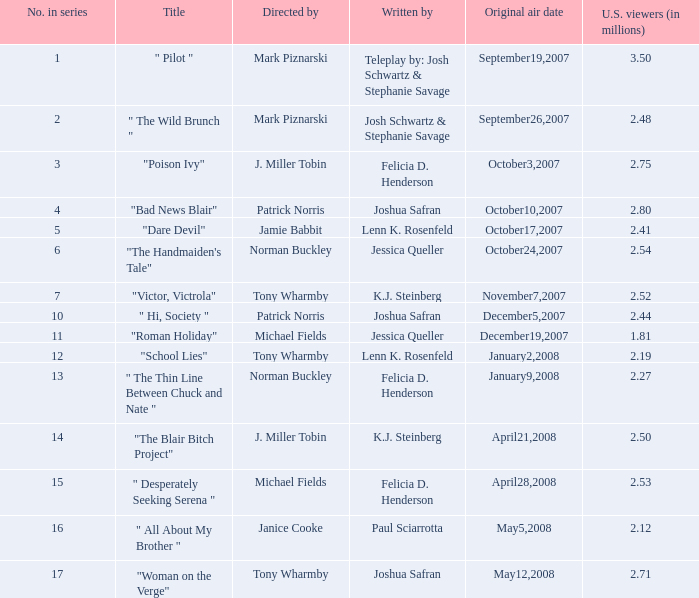What is the number of u.s. viewers (in millions) for the show "dare devil"? 2.41. 